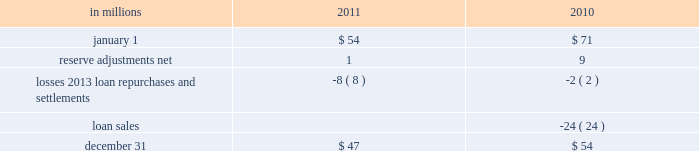Recourse and repurchase obligations as discussed in note 3 loans sale and servicing activities and variable interest entities , pnc has sold commercial mortgage and residential mortgage loans directly or indirectly in securitizations and whole-loan sale transactions with continuing involvement .
One form of continuing involvement includes certain recourse and loan repurchase obligations associated with the transferred assets in these transactions .
Commercial mortgage loan recourse obligations we originate , close and service certain multi-family commercial mortgage loans which are sold to fnma under fnma 2019s dus program .
We participated in a similar program with the fhlmc .
Under these programs , we generally assume up to a one-third pari passu risk of loss on unpaid principal balances through a loss share arrangement .
At december 31 , 2011 and december 31 , 2010 , the unpaid principal balance outstanding of loans sold as a participant in these programs was $ 13.0 billion and $ 13.2 billion , respectively .
The potential maximum exposure under the loss share arrangements was $ 4.0 billion at both december 31 , 2011 and december 31 , 2010 .
We maintain a reserve for estimated losses based upon our exposure .
The reserve for losses under these programs totaled $ 47 million and $ 54 million as of december 31 , 2011 and december 31 , 2010 , respectively , and is included in other liabilities on our consolidated balance sheet .
If payment is required under these programs , we would not have a contractual interest in the collateral underlying the mortgage loans on which losses occurred , although the value of the collateral is taken into account in determining our share of such losses .
Our exposure and activity associated with these recourse obligations are reported in the corporate & institutional banking segment .
Analysis of commercial mortgage recourse obligations .
Residential mortgage loan and home equity repurchase obligations while residential mortgage loans are sold on a non-recourse basis , we assume certain loan repurchase obligations associated with mortgage loans we have sold to investors .
These loan repurchase obligations primarily relate to situations where pnc is alleged to have breached certain origination covenants and representations and warranties made to purchasers of the loans in the respective purchase and sale agreements .
Residential mortgage loans covered by these loan repurchase obligations include first and second-lien mortgage loans we have sold through agency securitizations , non-agency securitizations , and whole-loan sale transactions .
As discussed in note 3 in this report , agency securitizations consist of mortgage loans sale transactions with fnma , fhlmc , and gnma , while non-agency securitizations and whole-loan sale transactions consist of mortgage loans sale transactions with private investors .
Our historical exposure and activity associated with agency securitization repurchase obligations has primarily been related to transactions with fnma and fhlmc , as indemnification and repurchase losses associated with fha and va-insured and uninsured loans pooled in gnma securitizations historically have been minimal .
Repurchase obligation activity associated with residential mortgages is reported in the residential mortgage banking segment .
Pnc 2019s repurchase obligations also include certain brokered home equity loans/lines that were sold to a limited number of private investors in the financial services industry by national city prior to our acquisition .
Pnc is no longer engaged in the brokered home equity lending business , and our exposure under these loan repurchase obligations is limited to repurchases of whole-loans sold in these transactions .
Repurchase activity associated with brokered home equity loans/lines is reported in the non-strategic assets portfolio segment .
Loan covenants and representations and warranties are established through loan sale agreements with various investors to provide assurance that pnc has sold loans to investors of sufficient investment quality .
Key aspects of such covenants and representations and warranties include the loan 2019s compliance with any applicable loan criteria established by the investor , including underwriting standards , delivery of all required loan documents to the investor or its designated party , sufficient collateral valuation , and the validity of the lien securing the loan .
As a result of alleged breaches of these contractual obligations , investors may request pnc to indemnify them against losses on certain loans or to repurchase loans .
These investor indemnification or repurchase claims are typically settled on an individual loan basis through make- whole payments or loan repurchases ; however , on occasion we may negotiate pooled settlements with investors .
Indemnifications for loss or loan repurchases typically occur when , after review of the claim , we agree insufficient evidence exists to dispute the investor 2019s claim that a breach of a loan covenant and representation and warranty has occurred , such breach has not been cured , and the effect of such breach is deemed to have had a material and adverse effect on the value of the transferred loan .
Depending on the sale agreement and upon proper notice from the investor , we typically respond to such indemnification and repurchase requests within 60 days , although final resolution of the claim may take a longer period of time .
With the exception of the sales the pnc financial services group , inc .
2013 form 10-k 199 .
If there were no loan sales in 2010 , what would the total amount of reserves available be , in millions , combined in 2010 and 2011 .? 
Rationale: add the 24m from the loan sales to the total number
Computations: ((47 + 54) + 24)
Answer: 125.0. 